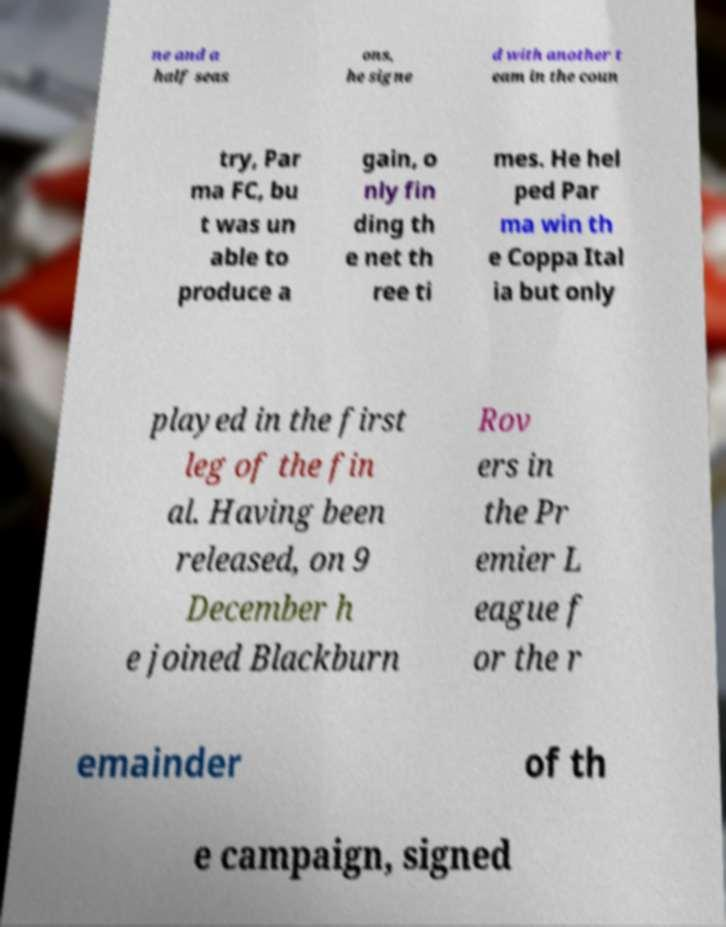What messages or text are displayed in this image? I need them in a readable, typed format. ne and a half seas ons, he signe d with another t eam in the coun try, Par ma FC, bu t was un able to produce a gain, o nly fin ding th e net th ree ti mes. He hel ped Par ma win th e Coppa Ital ia but only played in the first leg of the fin al. Having been released, on 9 December h e joined Blackburn Rov ers in the Pr emier L eague f or the r emainder of th e campaign, signed 